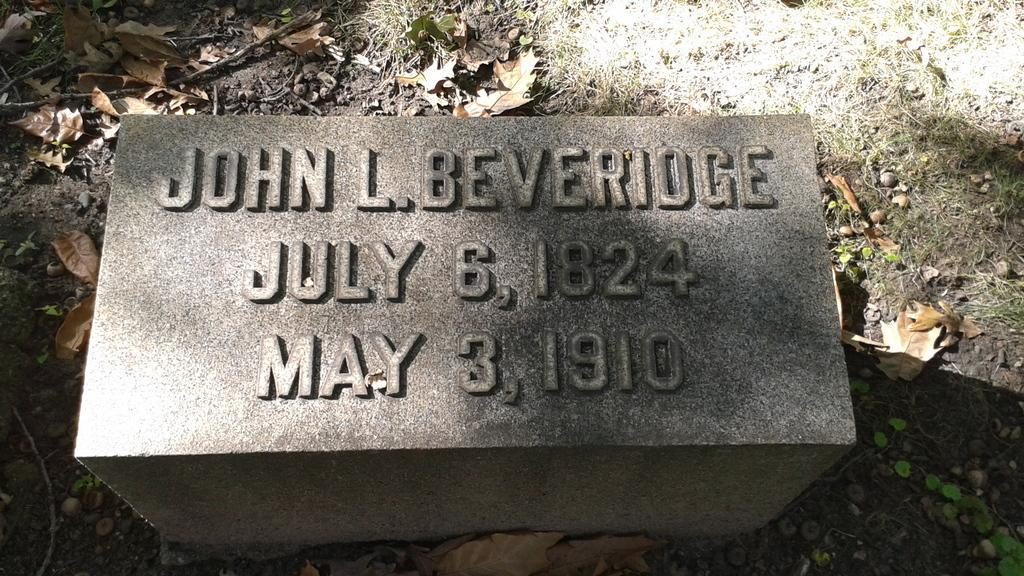What is the main object in the image? There is a headstone in the image. What information is engraved on the headstone? The headstone has a name, a date of birth, and a date of death engraved on it. What can be seen around the headstone? There are dry leaves and stones on the surface around the headstone. Can you see any wires connected to the headstone in the image? No, there are no wires connected to the headstone in the image. Is there a sea visible in the background of the image? No, there is no sea visible in the image; it is focused on the headstone and its surroundings. 